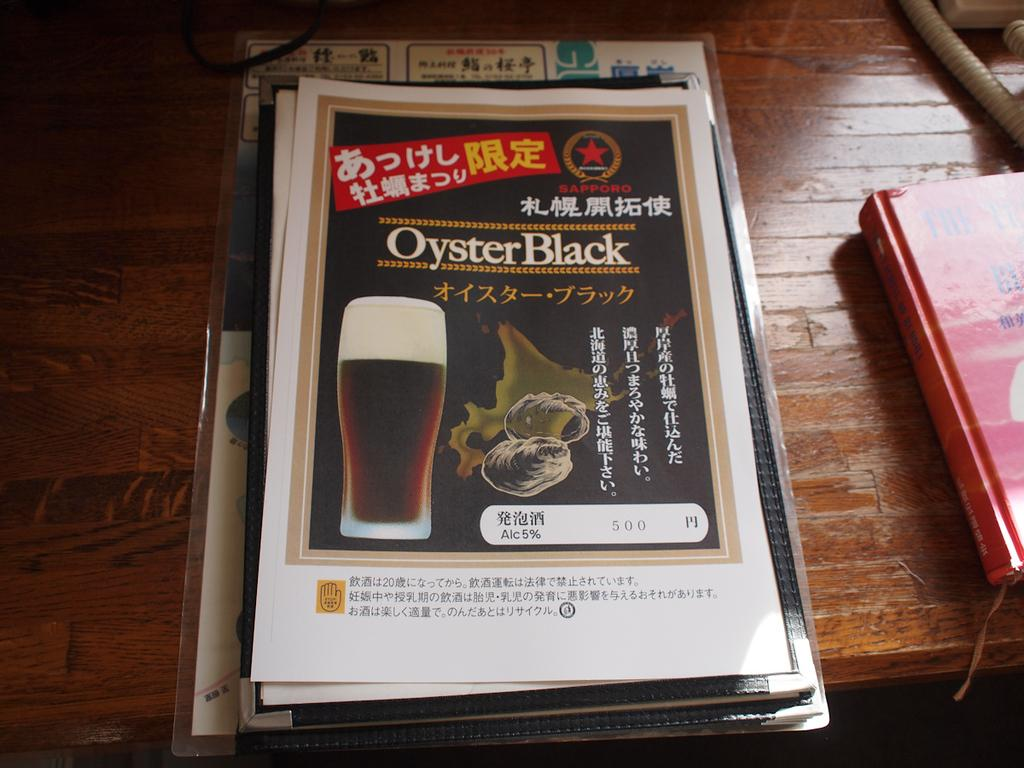<image>
Render a clear and concise summary of the photo. A stack of menus for Oyster Black sit on a table. 